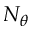<formula> <loc_0><loc_0><loc_500><loc_500>N _ { \theta }</formula> 